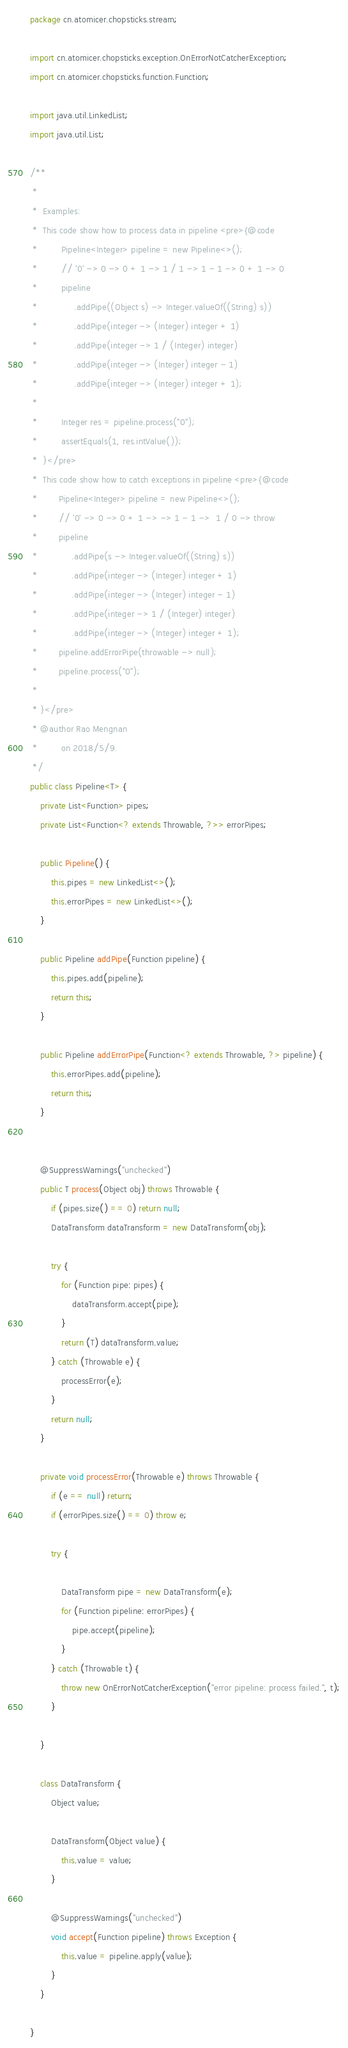<code> <loc_0><loc_0><loc_500><loc_500><_Java_>package cn.atomicer.chopsticks.stream;

import cn.atomicer.chopsticks.exception.OnErrorNotCatcherException;
import cn.atomicer.chopsticks.function.Function;

import java.util.LinkedList;
import java.util.List;

/**
 *
 *  Examples:
 *  This code show how to process data in pipeline <pre>{@code
 *         Pipeline<Integer> pipeline = new Pipeline<>();
 *         // '0' -> 0 -> 0 + 1 -> 1 / 1 -> 1 - 1 -> 0 + 1 -> 0
 *         pipeline
 *              .addPipe((Object s) -> Integer.valueOf((String) s))
 *              .addPipe(integer -> (Integer) integer + 1)
 *              .addPipe(integer -> 1 / (Integer) integer)
 *              .addPipe(integer -> (Integer) integer - 1)
 *              .addPipe(integer -> (Integer) integer + 1);
 *
 *         Integer res = pipeline.process("0");
 *         assertEquals(1, res.intValue());
 *  }</pre>
 *  This code show how to catch exceptions in pipeline <pre>{@code
 *        Pipeline<Integer> pipeline = new Pipeline<>();
 *        // '0' -> 0 -> 0 + 1 -> -> 1 - 1 ->  1 / 0 -> throw
 *        pipeline
 *             .addPipe(s -> Integer.valueOf((String) s))
 *             .addPipe(integer -> (Integer) integer + 1)
 *             .addPipe(integer -> (Integer) integer - 1)
 *             .addPipe(integer -> 1 / (Integer) integer)
 *             .addPipe(integer -> (Integer) integer + 1);
 *        pipeline.addErrorPipe(throwable -> null);
 *        pipeline.process("0");
 *
 * }</pre>
 * @author Rao Mengnan
 *         on 2018/5/9.
 */
public class Pipeline<T> {
    private List<Function> pipes;
    private List<Function<? extends Throwable, ?>> errorPipes;

    public Pipeline() {
        this.pipes = new LinkedList<>();
        this.errorPipes = new LinkedList<>();
    }

    public Pipeline addPipe(Function pipeline) {
        this.pipes.add(pipeline);
        return this;
    }

    public Pipeline addErrorPipe(Function<? extends Throwable, ?> pipeline) {
        this.errorPipes.add(pipeline);
        return this;
    }


    @SuppressWarnings("unchecked")
    public T process(Object obj) throws Throwable {
        if (pipes.size() == 0) return null;
        DataTransform dataTransform = new DataTransform(obj);

        try {
            for (Function pipe: pipes) {
                dataTransform.accept(pipe);
            }
            return (T) dataTransform.value;
        } catch (Throwable e) {
            processError(e);
        }
        return null;
    }

    private void processError(Throwable e) throws Throwable {
        if (e == null) return;
        if (errorPipes.size() == 0) throw e;

        try {

            DataTransform pipe = new DataTransform(e);
            for (Function pipeline: errorPipes) {
                pipe.accept(pipeline);
            }
        } catch (Throwable t) {
            throw new OnErrorNotCatcherException("error pipeline: process failed.", t);
        }

    }

    class DataTransform {
        Object value;

        DataTransform(Object value) {
            this.value = value;
        }

        @SuppressWarnings("unchecked")
        void accept(Function pipeline) throws Exception {
            this.value = pipeline.apply(value);
        }
    }

}
</code> 